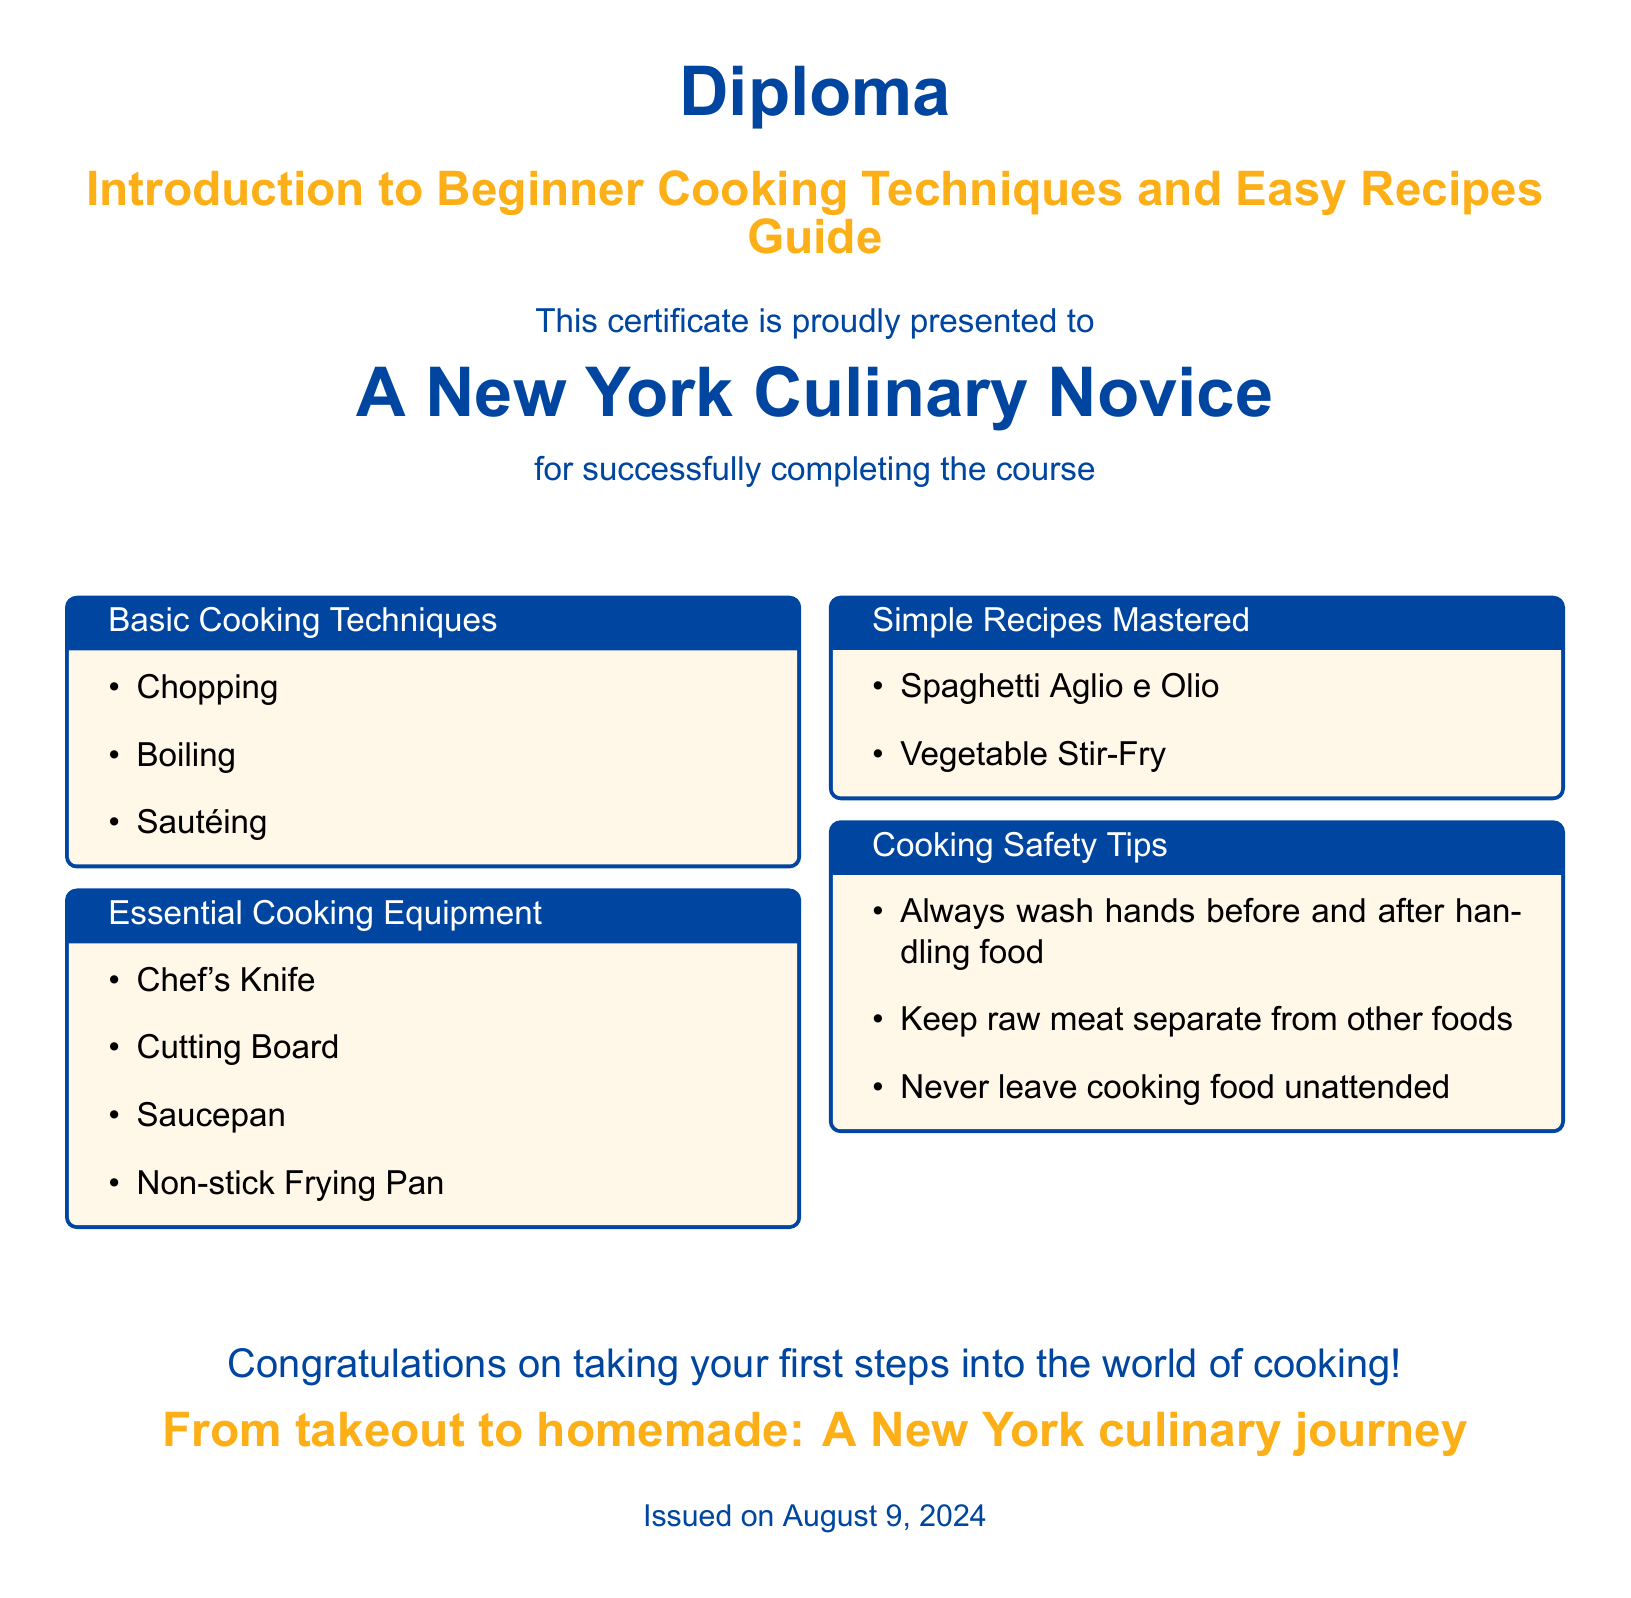What is the title of the diploma? The title of the diploma is prominently displayed in the document and is "Introduction to Beginner Cooking Techniques and Easy Recipes Guide."
Answer: Introduction to Beginner Cooking Techniques and Easy Recipes Guide Who is the diploma presented to? The diploma is presented to an individual referred to as "A New York Culinary Novice."
Answer: A New York Culinary Novice How many basic cooking techniques are listed? The document lists three basic cooking techniques in a box titled "Basic Cooking Techniques."
Answer: 3 What are the two simple recipes mastered? The document states two recipes under the "Simple Recipes Mastered" section: "Spaghetti Aglio e Olio" and "Vegetable Stir-Fry."
Answer: Spaghetti Aglio e Olio, Vegetable Stir-Fry What is one essential cooking equipment mentioned? The document lists "Chef's Knife" among the essential cooking equipment.
Answer: Chef's Knife What is the color used for the title of the diploma? The document uses a specific shade referred to as "nycblue" for the diploma title.
Answer: nycblue What is one cooking safety tip provided? One cooking safety tip mentioned is "Always wash hands before and after handling food."
Answer: Always wash hands before and after handling food How is the document concluded? The conclusion of the document includes a congratulatory message for taking the first steps into cooking, emphasizing the culinary journey.
Answer: Congratulations on taking your first steps into the world of cooking! 